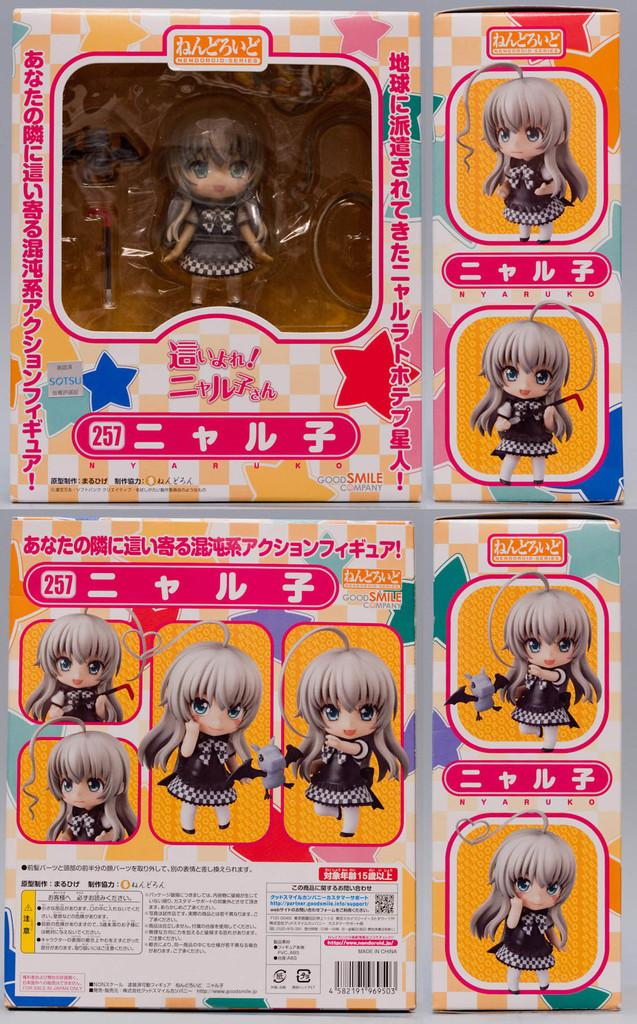What object is present in the image that might be used for storing toys? There is a toy box in the image. What type of toy can be found inside the toy box? The toy box contains a small girl toy. What additional information about the girl toy is provided in the image? There are pictures of the girl toy with different actions on the right side of the image. Where can instructions be found in the image? There are instructions at the bottom of the image. Can you tell me how many porters are helping to move the toy box in the image? There are no porters present in the image, and the toy box is not being moved. 